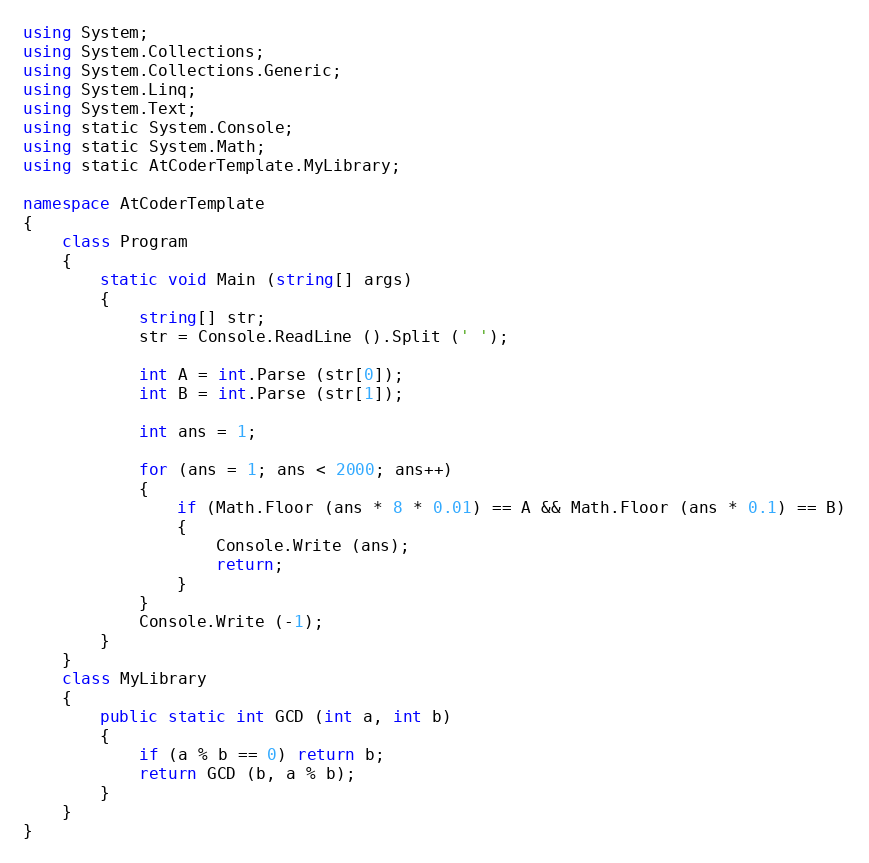Convert code to text. <code><loc_0><loc_0><loc_500><loc_500><_C#_>using System;
using System.Collections;
using System.Collections.Generic;
using System.Linq;
using System.Text;
using static System.Console;
using static System.Math;
using static AtCoderTemplate.MyLibrary;

namespace AtCoderTemplate
{
    class Program
    {
        static void Main (string[] args)
        {
            string[] str;
            str = Console.ReadLine ().Split (' ');

            int A = int.Parse (str[0]);
            int B = int.Parse (str[1]);

            int ans = 1;

            for (ans = 1; ans < 2000; ans++)
            {
                if (Math.Floor (ans * 8 * 0.01) == A && Math.Floor (ans * 0.1) == B)
                {
                    Console.Write (ans);
                    return;
                }
            }
            Console.Write (-1);
        }
    }
    class MyLibrary
    {
        public static int GCD (int a, int b)
        {
            if (a % b == 0) return b;
            return GCD (b, a % b);
        }
    }
}</code> 